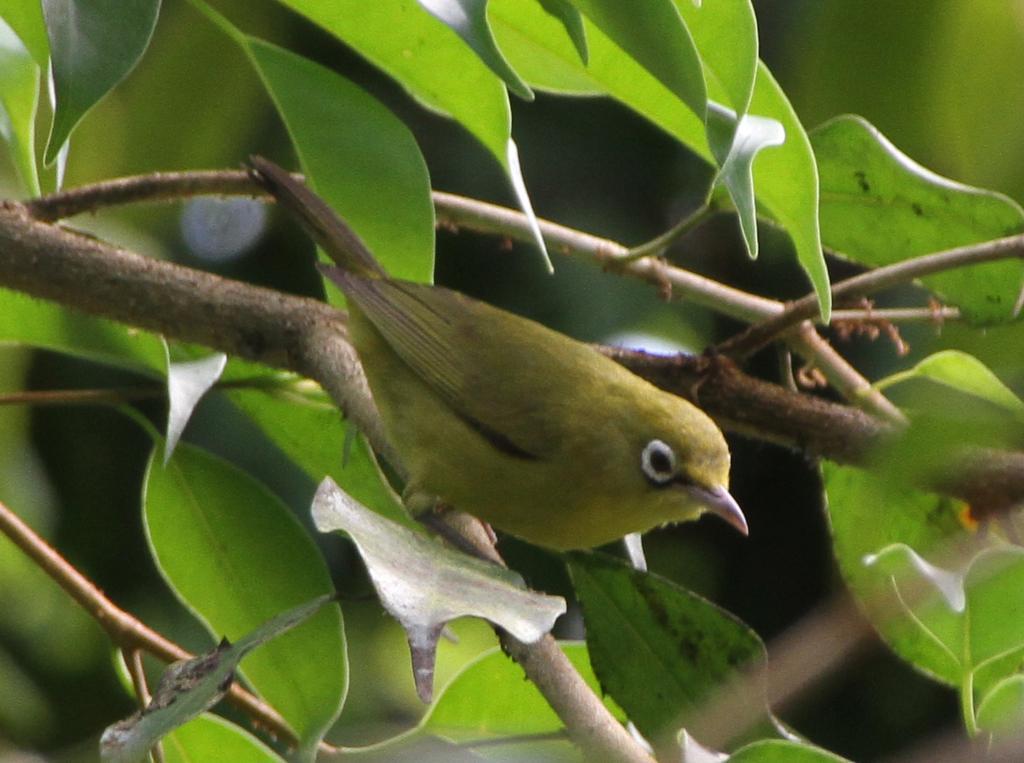Could you give a brief overview of what you see in this image? In this image on a stem there is a bird. In the background there are trees. The background is blurry. 